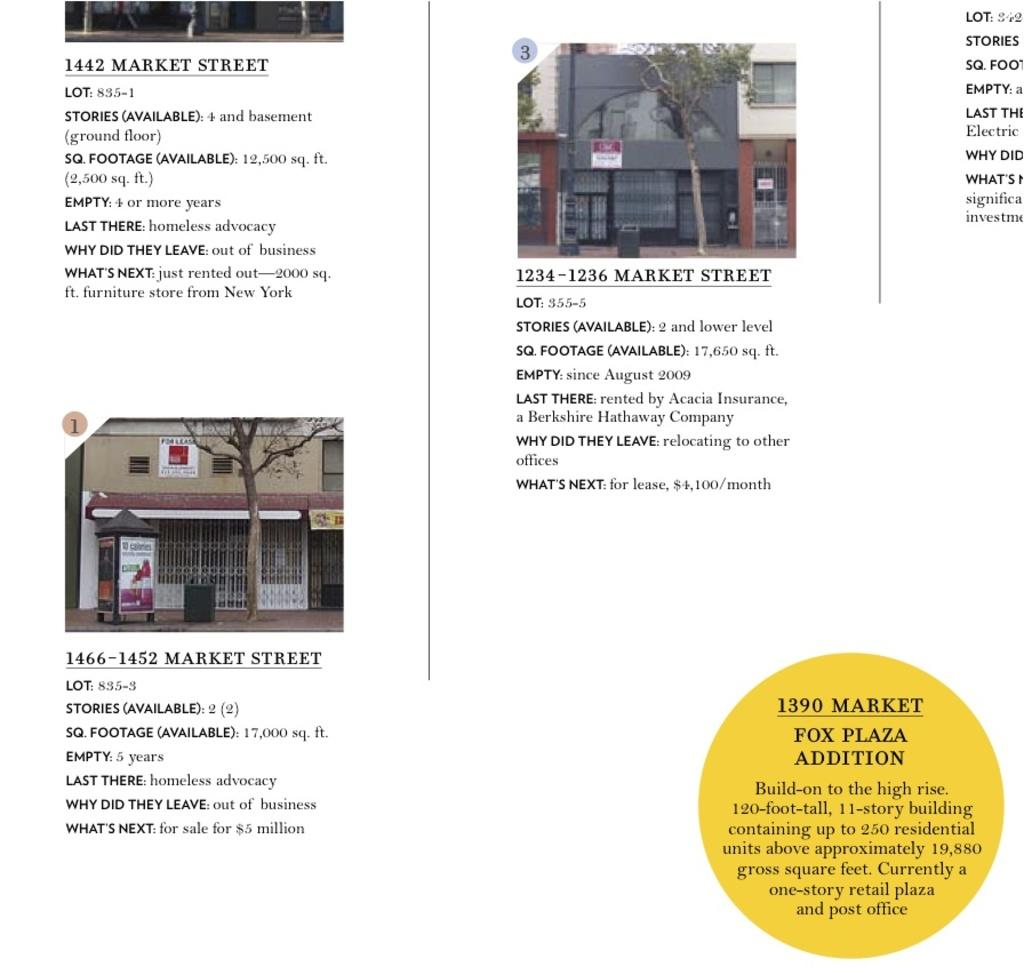How many buildings can be seen in the image? There are two buildings in the image. What else is present in the image besides the buildings? There is text in the image. What color is the background of the image? The background of the image is white. Reasoning: Let's think step by following the guidelines to produce the conversation. We start by identifying the main subjects in the image, which are the two buildings. Then, we expand the conversation to include other details that are also visible, such as the text and the white background. Each question is designed to elicit a specific detail about the image that is known from the provided facts. Absurd Question/Answer: What type of oil is being used to create the surprise in the image? There is no oil or surprise present in the image; it only features two buildings and text on a white background. 